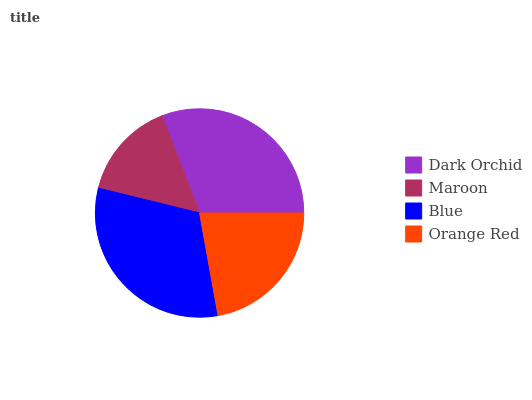Is Maroon the minimum?
Answer yes or no. Yes. Is Blue the maximum?
Answer yes or no. Yes. Is Blue the minimum?
Answer yes or no. No. Is Maroon the maximum?
Answer yes or no. No. Is Blue greater than Maroon?
Answer yes or no. Yes. Is Maroon less than Blue?
Answer yes or no. Yes. Is Maroon greater than Blue?
Answer yes or no. No. Is Blue less than Maroon?
Answer yes or no. No. Is Dark Orchid the high median?
Answer yes or no. Yes. Is Orange Red the low median?
Answer yes or no. Yes. Is Maroon the high median?
Answer yes or no. No. Is Dark Orchid the low median?
Answer yes or no. No. 